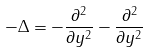<formula> <loc_0><loc_0><loc_500><loc_500>- \Delta = - \frac { \partial ^ { 2 } } { \partial y ^ { 2 } } - \frac { \partial ^ { 2 } } { \partial y ^ { 2 } }</formula> 